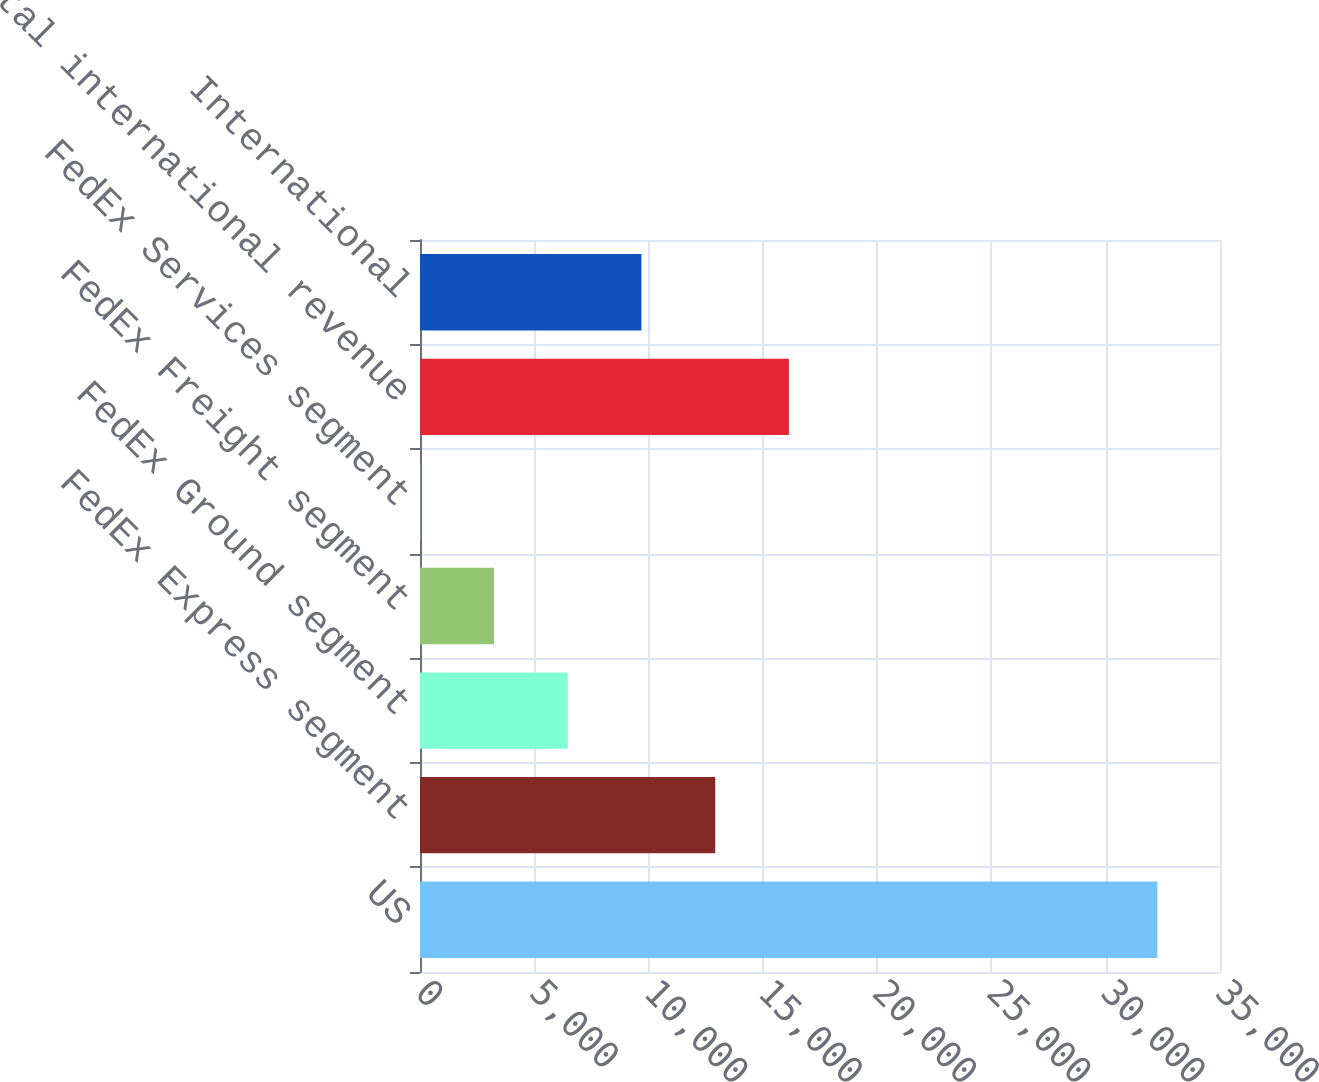Convert chart. <chart><loc_0><loc_0><loc_500><loc_500><bar_chart><fcel>US<fcel>FedEx Express segment<fcel>FedEx Ground segment<fcel>FedEx Freight segment<fcel>FedEx Services segment<fcel>Total international revenue<fcel>International<nl><fcel>32259<fcel>12916<fcel>6463<fcel>3238.5<fcel>14<fcel>16140.5<fcel>9687.5<nl></chart> 